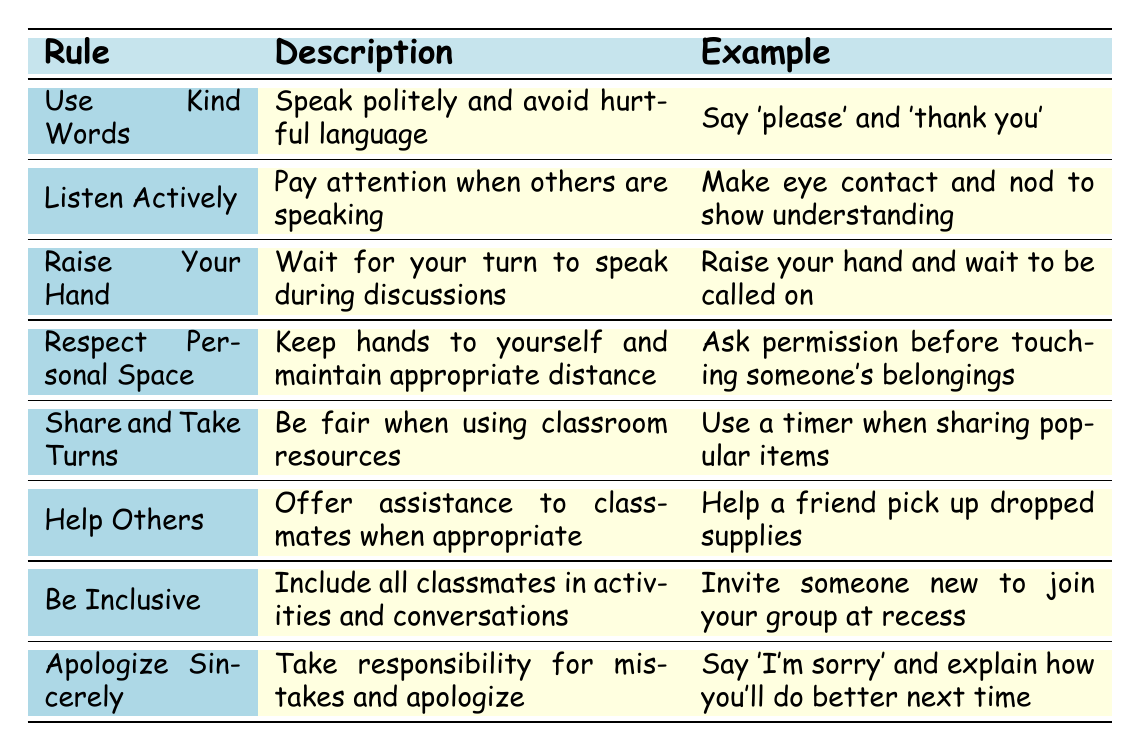What is the rule that encourages speaking politely? The table lists "Use Kind Words" as the rule encouraging polite speech.
Answer: Use Kind Words What is an example of "Listen Actively"? According to the table, an example is to "Make eye contact and nod to show understanding."
Answer: Make eye contact and nod to show understanding How many rules are listed in the table? The table contains 8 rules in total, as seen by counting each row under the header.
Answer: 8 Which rule advises students to keep their hands to themselves? The rule "Respect Personal Space" in the table addresses maintaining appropriate distance and keeping hands to oneself.
Answer: Respect Personal Space If you experience a conflict with a classmate, which rule would you follow to resolve it? You would follow the "Apologize Sincerely" rule, which emphasizes taking responsibility for mistakes and making amends.
Answer: Apologize Sincerely Is "Sharing and Taking Turns" included in the rules? Yes, "Share and Take Turns" is one of the rules listed in the table.
Answer: Yes Which rule includes the recommendation to invite someone new to join? The rule "Be Inclusive" mentions including all classmates in activities, specifically suggesting inviting someone new at recess.
Answer: Be Inclusive If a student follows all rules in the table, what would they likely demonstrate? Following all rules would demonstrate respectful behavior, as each rule aims to promote kindness, inclusiveness, and cooperation.
Answer: Respectful behavior What rule is not directly related to communication? "Help Others" focuses on offering assistance and is not about verbal communication.
Answer: Help Others 